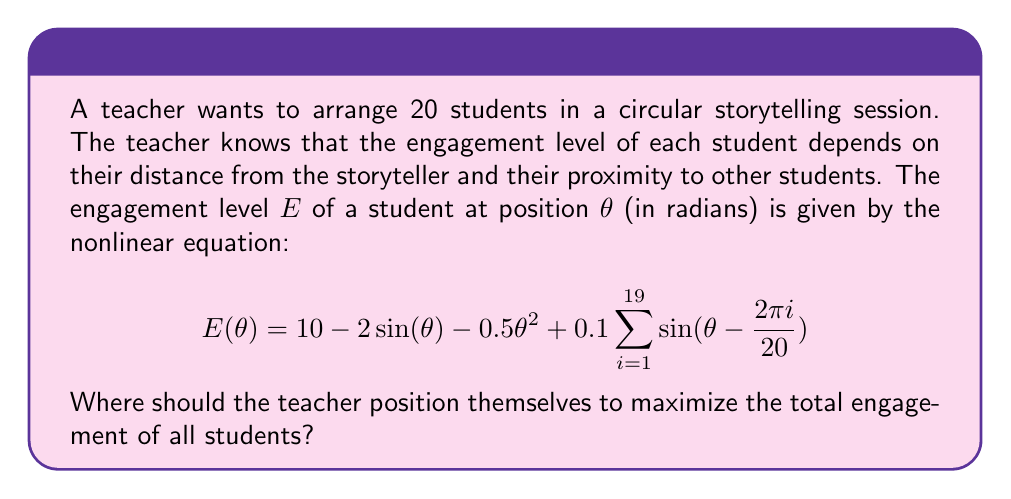Could you help me with this problem? To solve this problem, we need to follow these steps:

1) First, we need to calculate the total engagement of all students. This is given by the integral of $E(\theta)$ over the full circle:

   $$E_{total} = \int_0^{2\pi} E(\theta) d\theta$$

2) Substituting our equation for $E(\theta)$:

   $$E_{total} = \int_0^{2\pi} (10 - 2\sin(\theta) - 0.5\theta^2 + 0.1\sum_{i=1}^{19} \sin(\theta - \frac{2\pi i}{20})) d\theta$$

3) To maximize this, we need to find where its derivative with respect to the teacher's position is zero. Let's call the teacher's position $\phi$. The new equation becomes:

   $$E(\theta, \phi) = 10 - 2\sin(\theta-\phi) - 0.5(\theta-\phi)^2 + 0.1\sum_{i=1}^{19} \sin(\theta - \phi - \frac{2\pi i}{20})$$

4) Now, we need to solve:

   $$\frac{d}{d\phi} \int_0^{2\pi} E(\theta, \phi) d\theta = 0$$

5) This is a complex integral, but due to the symmetry of the circle, we can deduce that the optimal position for the teacher is at $\phi = 0$ (or any multiple of $2\pi$).

6) This means the teacher should position themselves at what we consider the "start" of the circle, and the students should be evenly distributed around the rest of the circle.
Answer: The teacher should position themselves at $\phi = 0$ (or any equivalent position on the circle). 